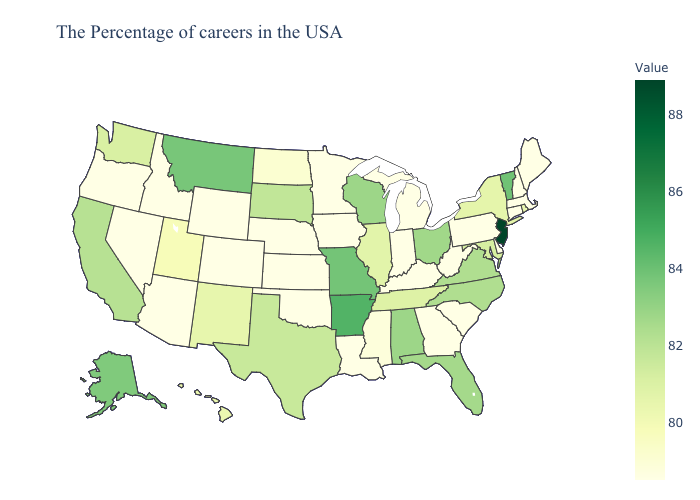Does Missouri have the highest value in the MidWest?
Be succinct. Yes. Among the states that border Oregon , does Nevada have the lowest value?
Answer briefly. Yes. Does South Dakota have a higher value than Arizona?
Short answer required. Yes. Does New Hampshire have a lower value than Texas?
Concise answer only. Yes. 